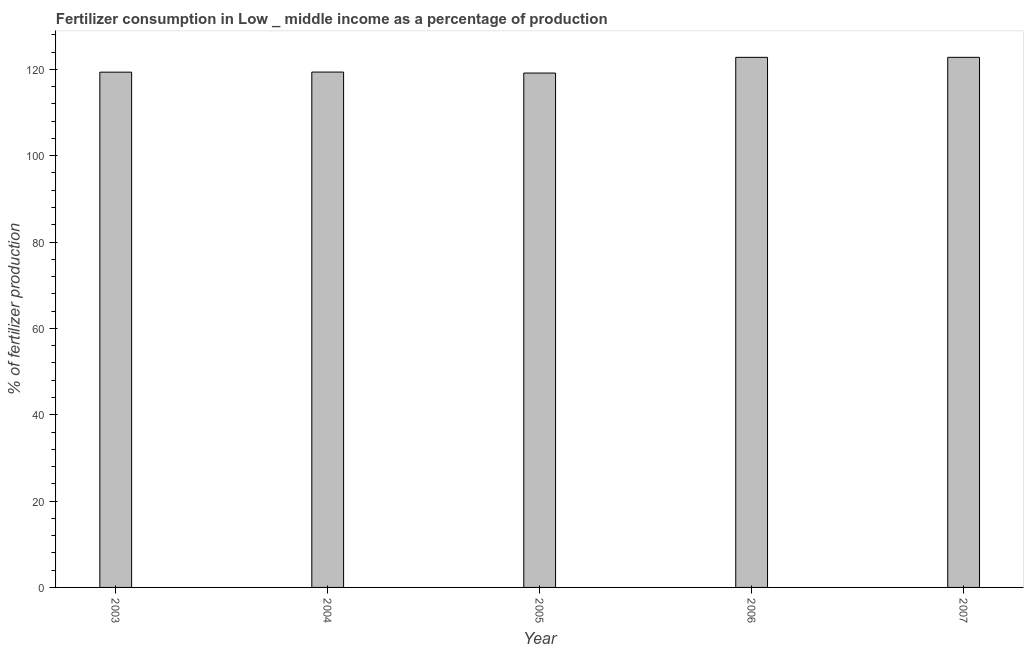Does the graph contain any zero values?
Provide a short and direct response. No. Does the graph contain grids?
Provide a succinct answer. No. What is the title of the graph?
Offer a very short reply. Fertilizer consumption in Low _ middle income as a percentage of production. What is the label or title of the X-axis?
Make the answer very short. Year. What is the label or title of the Y-axis?
Ensure brevity in your answer.  % of fertilizer production. What is the amount of fertilizer consumption in 2005?
Your answer should be very brief. 119.15. Across all years, what is the maximum amount of fertilizer consumption?
Keep it short and to the point. 122.79. Across all years, what is the minimum amount of fertilizer consumption?
Your answer should be compact. 119.15. In which year was the amount of fertilizer consumption maximum?
Offer a terse response. 2007. What is the sum of the amount of fertilizer consumption?
Provide a succinct answer. 603.47. What is the difference between the amount of fertilizer consumption in 2005 and 2006?
Your response must be concise. -3.64. What is the average amount of fertilizer consumption per year?
Offer a terse response. 120.69. What is the median amount of fertilizer consumption?
Offer a terse response. 119.38. In how many years, is the amount of fertilizer consumption greater than 100 %?
Keep it short and to the point. 5. Do a majority of the years between 2003 and 2006 (inclusive) have amount of fertilizer consumption greater than 32 %?
Provide a short and direct response. Yes. Is the amount of fertilizer consumption in 2003 less than that in 2007?
Offer a terse response. Yes. What is the difference between the highest and the second highest amount of fertilizer consumption?
Your response must be concise. 0.01. What is the difference between the highest and the lowest amount of fertilizer consumption?
Give a very brief answer. 3.64. How many years are there in the graph?
Your response must be concise. 5. What is the difference between two consecutive major ticks on the Y-axis?
Provide a short and direct response. 20. Are the values on the major ticks of Y-axis written in scientific E-notation?
Offer a terse response. No. What is the % of fertilizer production of 2003?
Provide a succinct answer. 119.36. What is the % of fertilizer production in 2004?
Offer a very short reply. 119.38. What is the % of fertilizer production of 2005?
Provide a succinct answer. 119.15. What is the % of fertilizer production in 2006?
Ensure brevity in your answer.  122.79. What is the % of fertilizer production of 2007?
Give a very brief answer. 122.79. What is the difference between the % of fertilizer production in 2003 and 2004?
Provide a succinct answer. -0.02. What is the difference between the % of fertilizer production in 2003 and 2005?
Provide a succinct answer. 0.2. What is the difference between the % of fertilizer production in 2003 and 2006?
Make the answer very short. -3.43. What is the difference between the % of fertilizer production in 2003 and 2007?
Offer a very short reply. -3.44. What is the difference between the % of fertilizer production in 2004 and 2005?
Offer a terse response. 0.23. What is the difference between the % of fertilizer production in 2004 and 2006?
Provide a short and direct response. -3.41. What is the difference between the % of fertilizer production in 2004 and 2007?
Offer a terse response. -3.42. What is the difference between the % of fertilizer production in 2005 and 2006?
Your answer should be very brief. -3.64. What is the difference between the % of fertilizer production in 2005 and 2007?
Provide a succinct answer. -3.64. What is the difference between the % of fertilizer production in 2006 and 2007?
Provide a succinct answer. -0.01. What is the ratio of the % of fertilizer production in 2003 to that in 2004?
Keep it short and to the point. 1. What is the ratio of the % of fertilizer production in 2003 to that in 2005?
Provide a succinct answer. 1. What is the ratio of the % of fertilizer production in 2004 to that in 2006?
Provide a short and direct response. 0.97. What is the ratio of the % of fertilizer production in 2004 to that in 2007?
Offer a terse response. 0.97. What is the ratio of the % of fertilizer production in 2005 to that in 2007?
Make the answer very short. 0.97. What is the ratio of the % of fertilizer production in 2006 to that in 2007?
Your answer should be very brief. 1. 